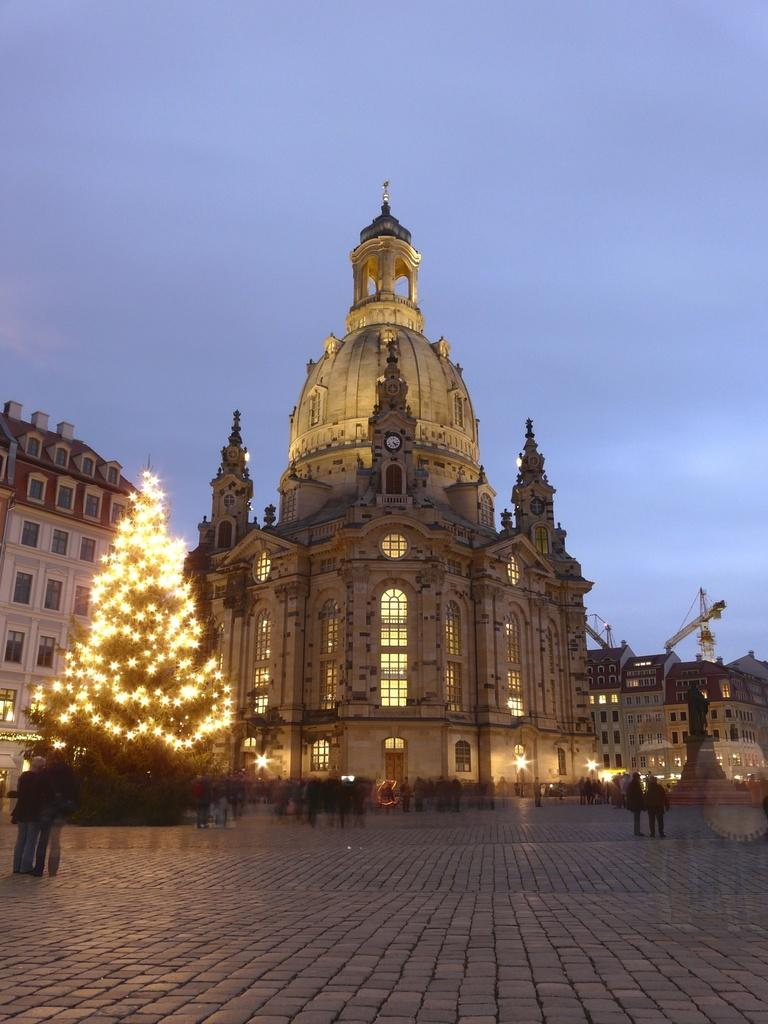What type of structures are visible in the image? There are buildings in the image. What is located in front of the buildings? There are persons and a tree in front of the buildings. What is special about the tree in front of the buildings? The tree has lights on it. What can be seen at the top of the image? The sky is visible at the top of the image. What type of meal is being served on the tree in the image? There is no meal present on the tree in the image; it has lights on it. 